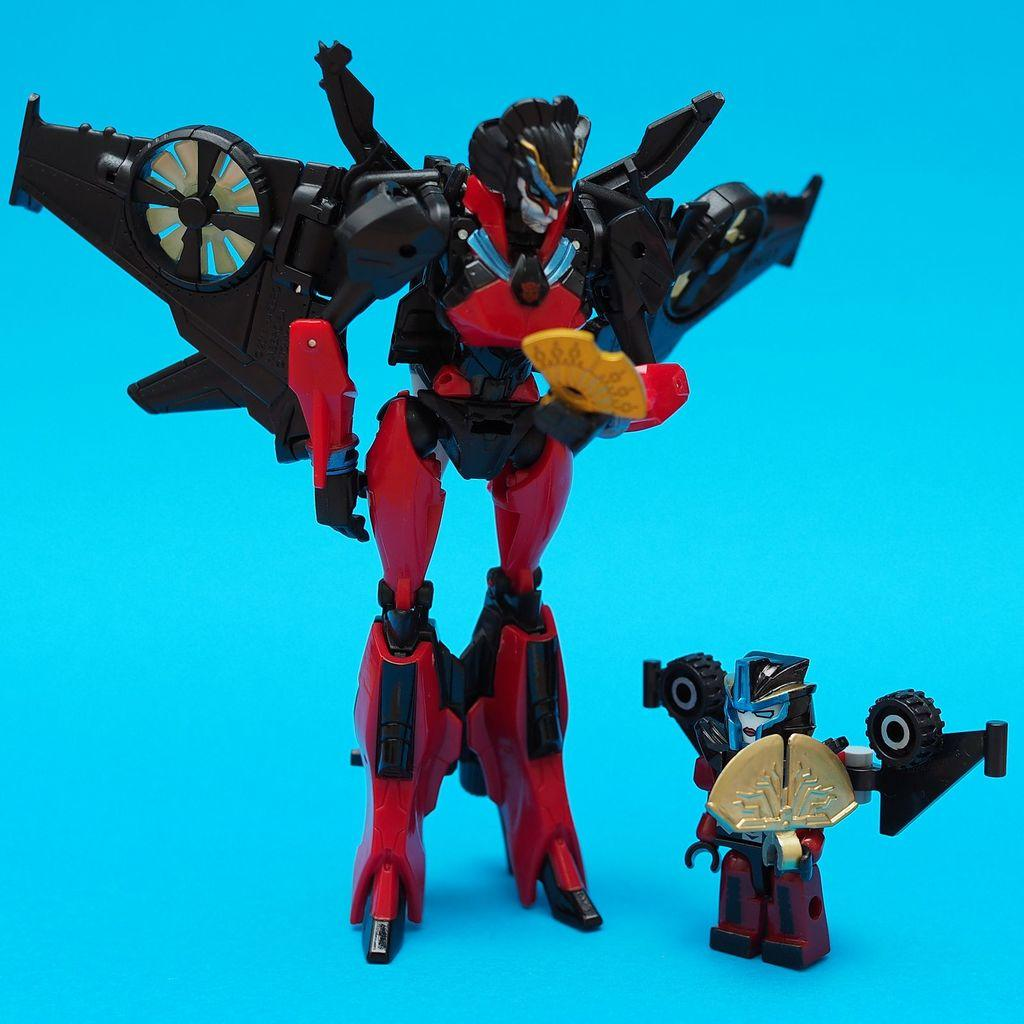What color is the background of the image? The background of the image is blue. What can be seen in the middle of the image? There are two robots in the middle of the image. How are the robots transporting people in the image? There is no indication in the image that the robots are transporting people or involved in any form of transportation. 